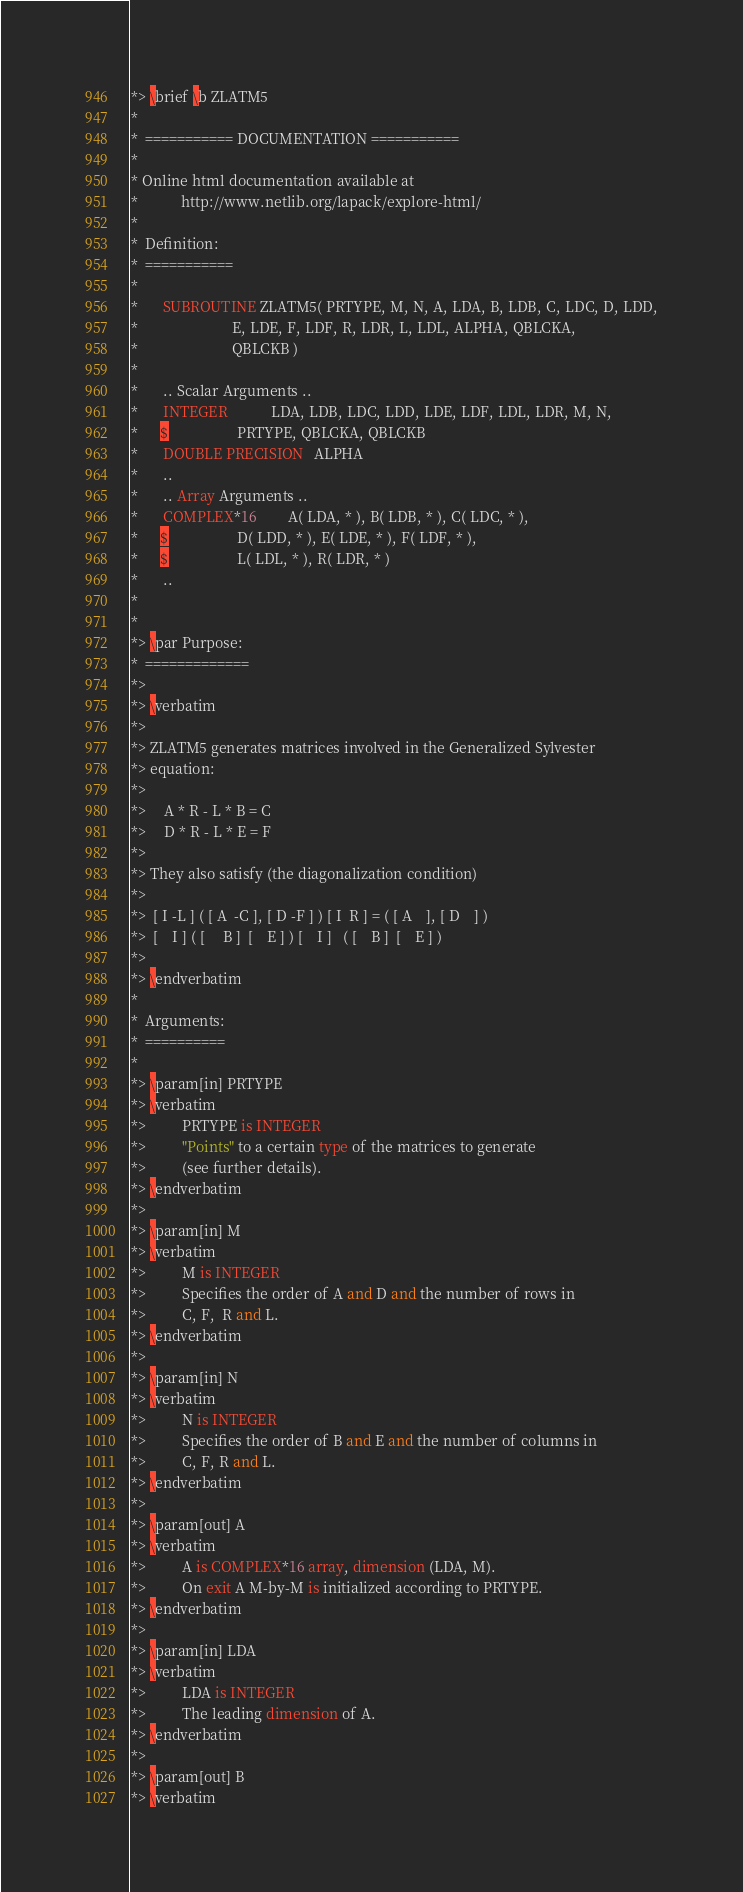Convert code to text. <code><loc_0><loc_0><loc_500><loc_500><_FORTRAN_>*> \brief \b ZLATM5
*
*  =========== DOCUMENTATION ===========
*
* Online html documentation available at
*            http://www.netlib.org/lapack/explore-html/
*
*  Definition:
*  ===========
*
*       SUBROUTINE ZLATM5( PRTYPE, M, N, A, LDA, B, LDB, C, LDC, D, LDD,
*                          E, LDE, F, LDF, R, LDR, L, LDL, ALPHA, QBLCKA,
*                          QBLCKB )
*
*       .. Scalar Arguments ..
*       INTEGER            LDA, LDB, LDC, LDD, LDE, LDF, LDL, LDR, M, N,
*      $                   PRTYPE, QBLCKA, QBLCKB
*       DOUBLE PRECISION   ALPHA
*       ..
*       .. Array Arguments ..
*       COMPLEX*16         A( LDA, * ), B( LDB, * ), C( LDC, * ),
*      $                   D( LDD, * ), E( LDE, * ), F( LDF, * ),
*      $                   L( LDL, * ), R( LDR, * )
*       ..
*
*
*> \par Purpose:
*  =============
*>
*> \verbatim
*>
*> ZLATM5 generates matrices involved in the Generalized Sylvester
*> equation:
*>
*>     A * R - L * B = C
*>     D * R - L * E = F
*>
*> They also satisfy (the diagonalization condition)
*>
*>  [ I -L ] ( [ A  -C ], [ D -F ] ) [ I  R ] = ( [ A    ], [ D    ] )
*>  [    I ] ( [     B ]  [    E ] ) [    I ]   ( [    B ]  [    E ] )
*>
*> \endverbatim
*
*  Arguments:
*  ==========
*
*> \param[in] PRTYPE
*> \verbatim
*>          PRTYPE is INTEGER
*>          "Points" to a certain type of the matrices to generate
*>          (see further details).
*> \endverbatim
*>
*> \param[in] M
*> \verbatim
*>          M is INTEGER
*>          Specifies the order of A and D and the number of rows in
*>          C, F,  R and L.
*> \endverbatim
*>
*> \param[in] N
*> \verbatim
*>          N is INTEGER
*>          Specifies the order of B and E and the number of columns in
*>          C, F, R and L.
*> \endverbatim
*>
*> \param[out] A
*> \verbatim
*>          A is COMPLEX*16 array, dimension (LDA, M).
*>          On exit A M-by-M is initialized according to PRTYPE.
*> \endverbatim
*>
*> \param[in] LDA
*> \verbatim
*>          LDA is INTEGER
*>          The leading dimension of A.
*> \endverbatim
*>
*> \param[out] B
*> \verbatim</code> 